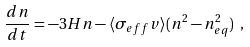<formula> <loc_0><loc_0><loc_500><loc_500>\frac { d n } { d t } = - 3 H n - \langle \sigma _ { e f f } v \rangle ( n ^ { 2 } - n ^ { 2 } _ { e q } ) \ ,</formula> 